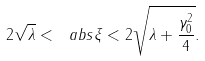<formula> <loc_0><loc_0><loc_500><loc_500>2 \sqrt { \lambda } < \ a b s { \xi } < 2 \sqrt { \lambda + \frac { \gamma _ { 0 } ^ { 2 } } { 4 } } .</formula> 